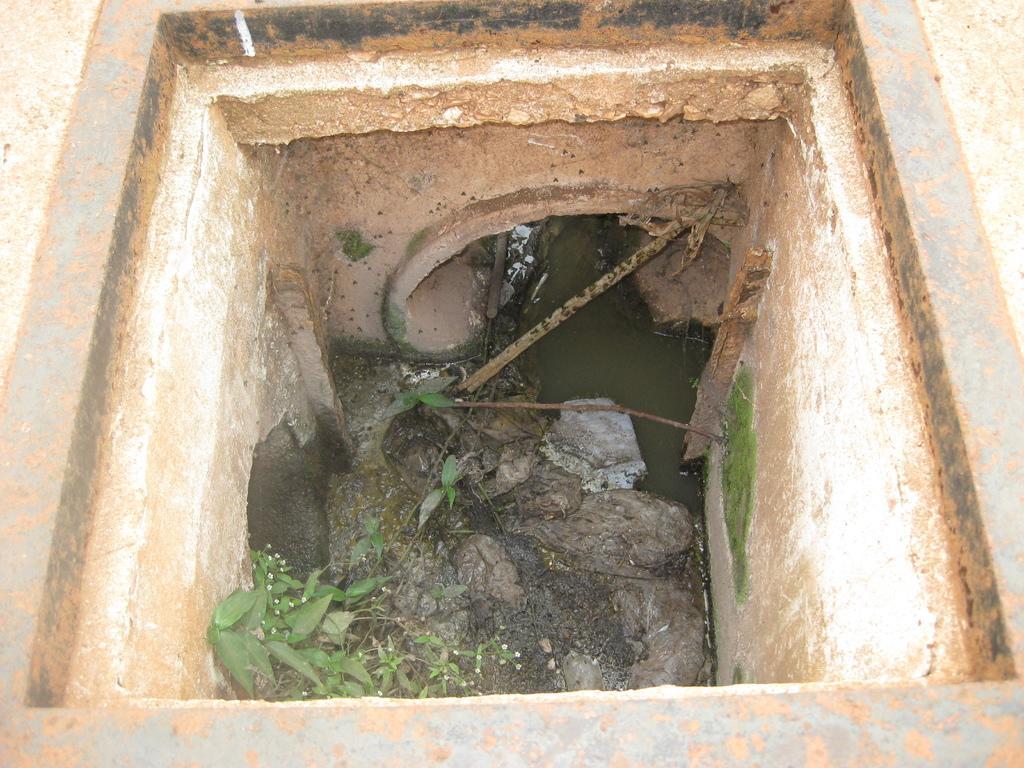How would you summarize this image in a sentence or two? The picture consists of a drainage pit. In the center there are leaves, pipe and wastewater. At the top it is cement road and there is an iron frame. 